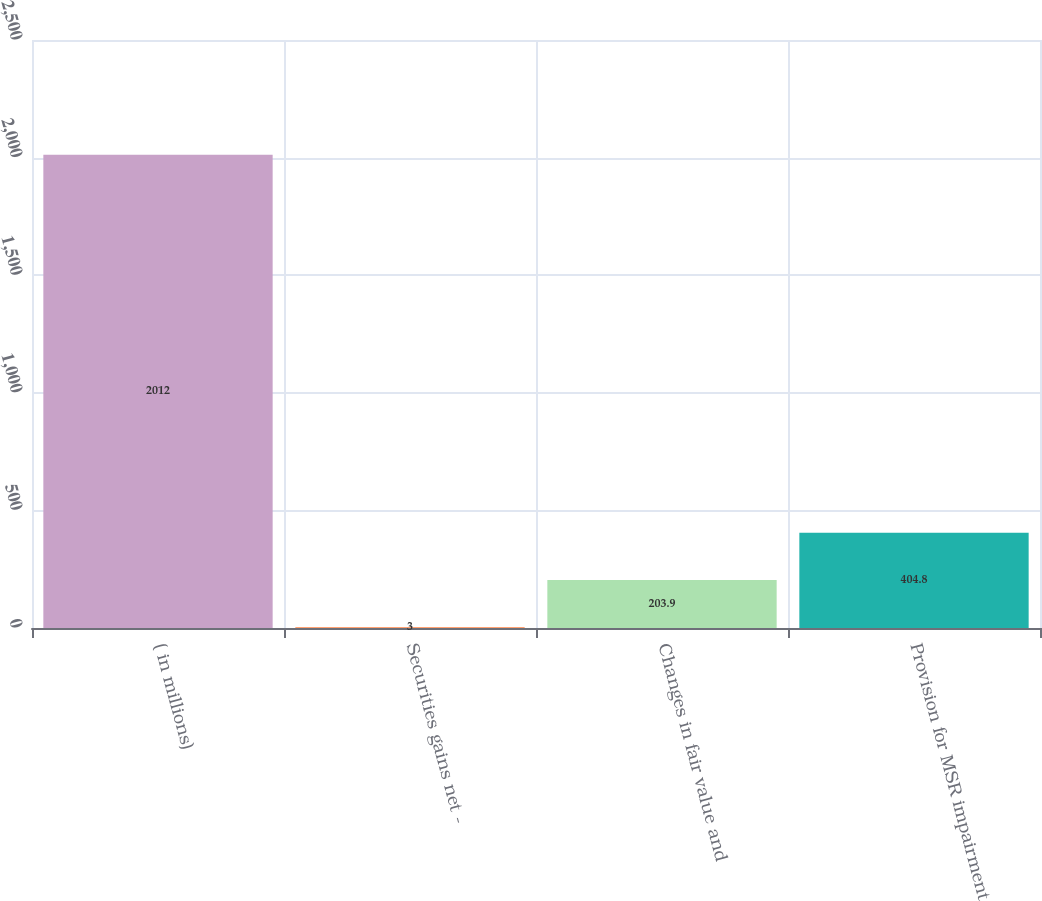Convert chart. <chart><loc_0><loc_0><loc_500><loc_500><bar_chart><fcel>( in millions)<fcel>Securities gains net -<fcel>Changes in fair value and<fcel>Provision for MSR impairment<nl><fcel>2012<fcel>3<fcel>203.9<fcel>404.8<nl></chart> 